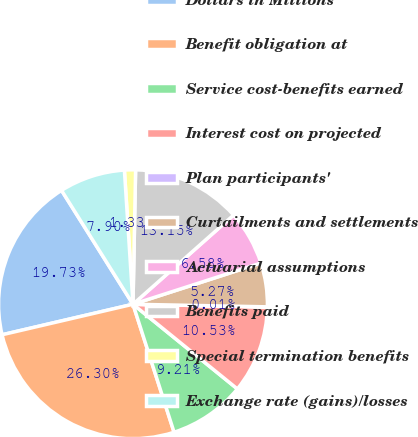Convert chart to OTSL. <chart><loc_0><loc_0><loc_500><loc_500><pie_chart><fcel>Dollars in Millions<fcel>Benefit obligation at<fcel>Service cost-benefits earned<fcel>Interest cost on projected<fcel>Plan participants'<fcel>Curtailments and settlements<fcel>Actuarial assumptions<fcel>Benefits paid<fcel>Special termination benefits<fcel>Exchange rate (gains)/losses<nl><fcel>19.73%<fcel>26.3%<fcel>9.21%<fcel>10.53%<fcel>0.01%<fcel>5.27%<fcel>6.58%<fcel>13.15%<fcel>1.33%<fcel>7.9%<nl></chart> 